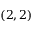Convert formula to latex. <formula><loc_0><loc_0><loc_500><loc_500>( 2 , 2 )</formula> 